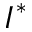<formula> <loc_0><loc_0><loc_500><loc_500>I ^ { * }</formula> 